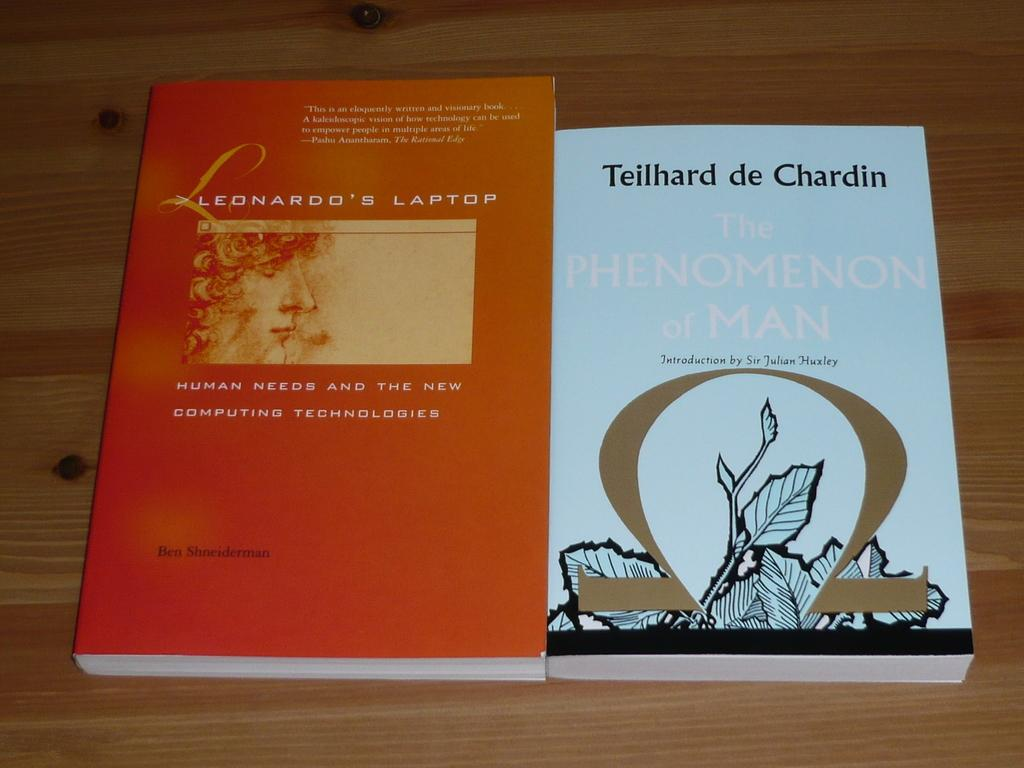<image>
Present a compact description of the photo's key features. Two books side by side, one of which is titled Human Needs and the New Computing Technologies. 